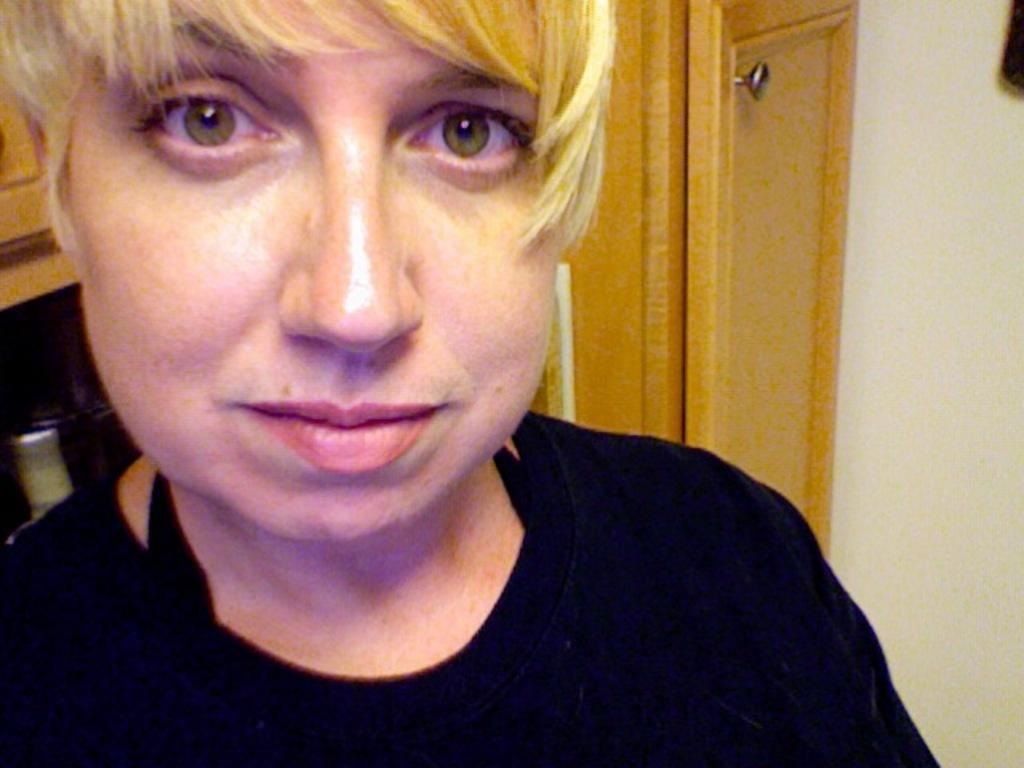Who is the main subject in the image? There is a woman in the image. What is the woman doing in the image? The woman is looking to one side. What is the woman wearing in the image? The woman is wearing a black t-shirt. What can be seen on the right side of the image? There is a door on the right side of the image. What type of pie is the woman holding in the image? There is no pie present in the image; the woman is not holding anything. 